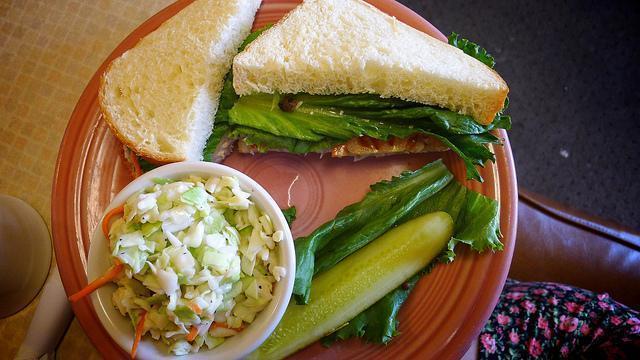From which vegetable is the main side dish sourced from mainly?
Indicate the correct response by choosing from the four available options to answer the question.
Options: Lettuce, cabbage, apples, pears. Cabbage. 